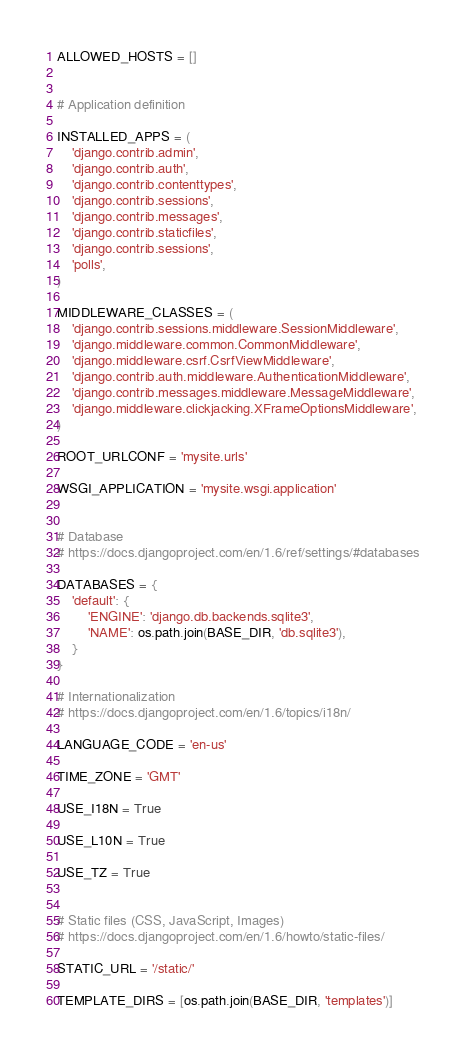Convert code to text. <code><loc_0><loc_0><loc_500><loc_500><_Python_>
ALLOWED_HOSTS = []


# Application definition

INSTALLED_APPS = (
    'django.contrib.admin',
    'django.contrib.auth',
    'django.contrib.contenttypes',
    'django.contrib.sessions',
    'django.contrib.messages',
    'django.contrib.staticfiles',
    'django.contrib.sessions',
    'polls',
)

MIDDLEWARE_CLASSES = (
    'django.contrib.sessions.middleware.SessionMiddleware',
    'django.middleware.common.CommonMiddleware',
    'django.middleware.csrf.CsrfViewMiddleware',
    'django.contrib.auth.middleware.AuthenticationMiddleware',
    'django.contrib.messages.middleware.MessageMiddleware',
    'django.middleware.clickjacking.XFrameOptionsMiddleware',
)

ROOT_URLCONF = 'mysite.urls'

WSGI_APPLICATION = 'mysite.wsgi.application'


# Database
# https://docs.djangoproject.com/en/1.6/ref/settings/#databases

DATABASES = {
    'default': {
        'ENGINE': 'django.db.backends.sqlite3',
        'NAME': os.path.join(BASE_DIR, 'db.sqlite3'),
    }
}

# Internationalization
# https://docs.djangoproject.com/en/1.6/topics/i18n/

LANGUAGE_CODE = 'en-us'

TIME_ZONE = 'GMT'

USE_I18N = True

USE_L10N = True

USE_TZ = True


# Static files (CSS, JavaScript, Images)
# https://docs.djangoproject.com/en/1.6/howto/static-files/

STATIC_URL = '/static/'

TEMPLATE_DIRS = [os.path.join(BASE_DIR, 'templates')]</code> 